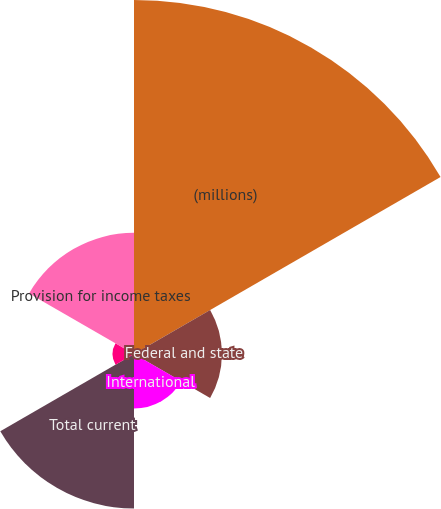Convert chart to OTSL. <chart><loc_0><loc_0><loc_500><loc_500><pie_chart><fcel>(millions)<fcel>Federal and state<fcel>International<fcel>Total current<fcel>Total deferred<fcel>Provision for income taxes<nl><fcel>44.62%<fcel>11.08%<fcel>6.88%<fcel>19.46%<fcel>2.69%<fcel>15.27%<nl></chart> 